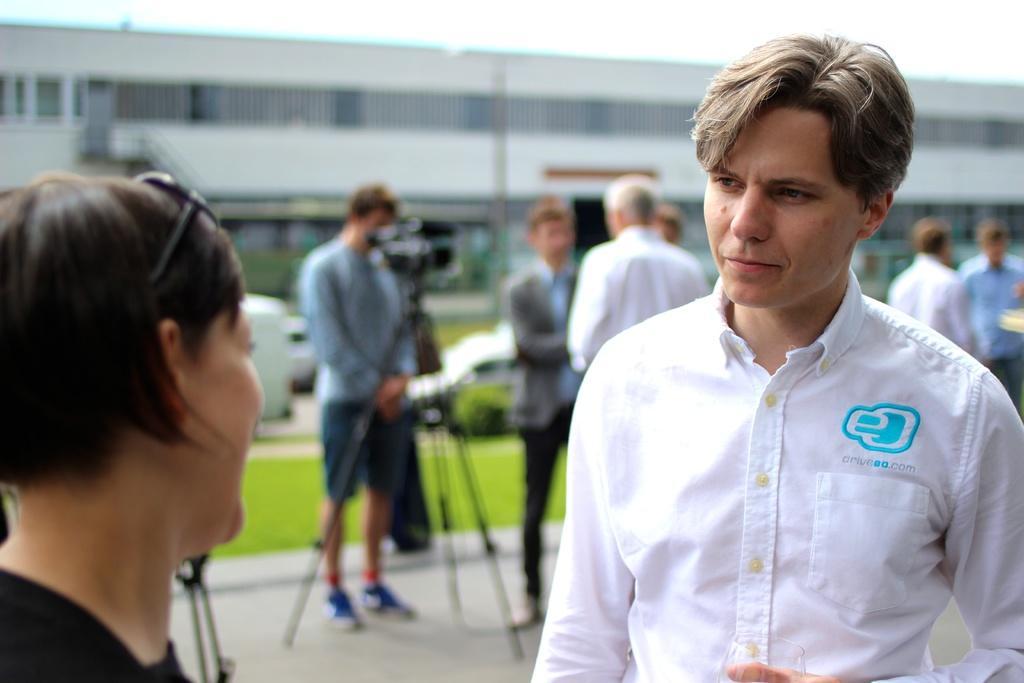Could you give a brief overview of what you see in this image? In this image I can see number of people are standing and in the centre of this image I can see a tripod stand and on it I can see a camera. In the background I can see grass ground, few vehicles, a building and I can see this image is little bit blurry in the background. 